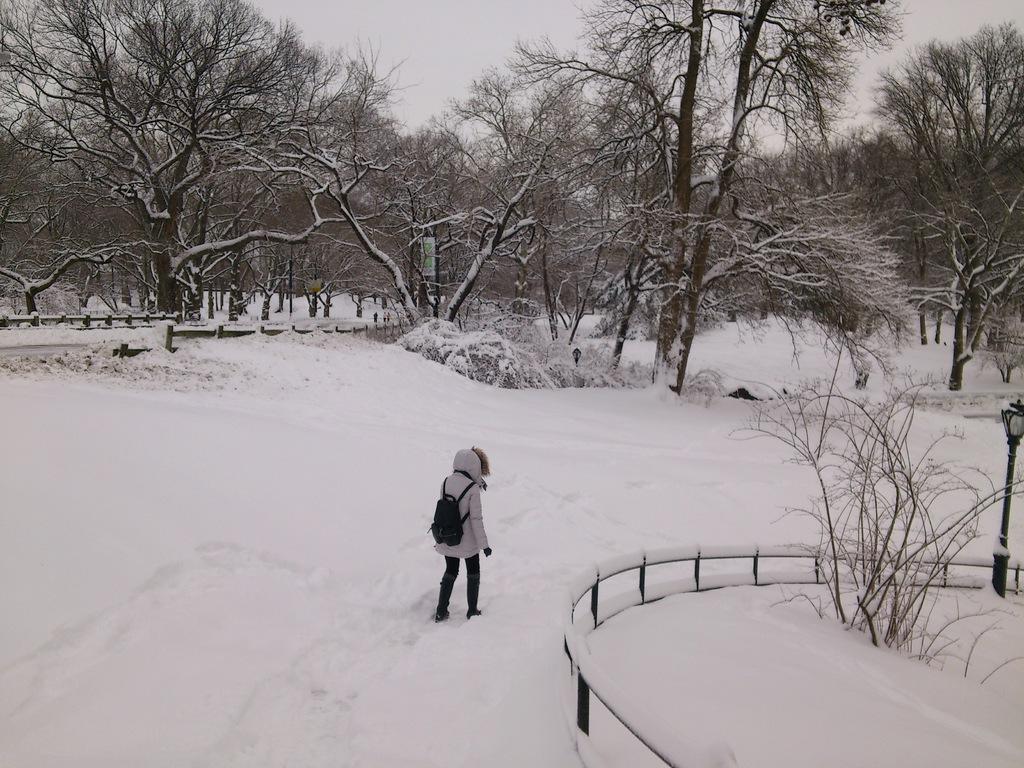Please provide a concise description of this image. In this image we can see a person wearing jacket and backpack walking on the snow, there is a fencing, plants, trees, light pole, also we can see the sky. 